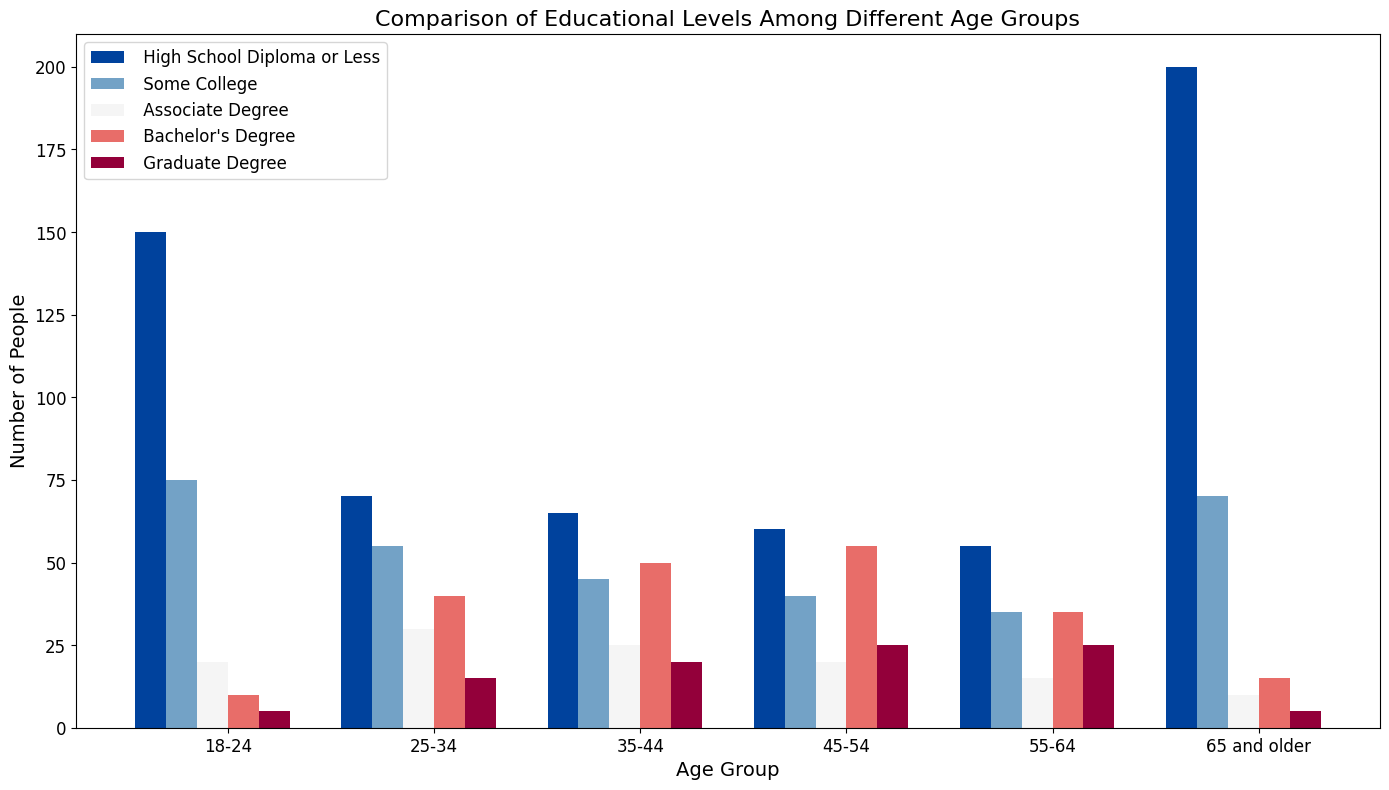What age group has the highest number of people with a High School Diploma or Less? Observe the heights of the bars for "High School Diploma or Less" in each age group. The tallest bar is for the "65 and older" group.
Answer: 65 and older Which age group has more people with a Bachelor's Degree, 35-44 or 45-54? Compare the heights of the bars for "Bachelor's Degree" in the 35-44 and 45-54 age groups. The 45-54 age group has a taller bar.
Answer: 45-54 What is the total number of people with Graduate Degrees in the 25-34 and 55-64 age groups? Find the numbers for "Graduate Degree" in the 25-34 and 55-64 age groups and add them together: 15 + 25.
Answer: 40 Which age group has the smallest number of people with an Associate Degree? Compare the heights of the bars for "Associate Degree" in each age group. The shortest bar is for the "65 and older" group.
Answer: 65 and older How does the number of people with Some College in the 18-24 age group compare to the 65 and older age group? Observe the heights of the bars for "Some College" in the 18-24 and 65 and older age groups. Both bars are about the same height.
Answer: Equal Which educational level has the most people in the 45-54 age group? Look at the heights of all bars in the 45-54 age group. The tallest bar is for "Bachelor's Degree".
Answer: Bachelor's Degree How many more people have a High School Diploma or Less in the 18-24 age group compared to the 25-34 age group? Subtract the number for "High School Diploma or Less" in the 25-34 age group from the 18-24 age group: 150 - 70.
Answer: 80 Which age group has the greatest variation in educational levels? Look at the differences in bar heights within each age group. The 18-24 and 65 and older groups show significant variation. The 65 and older group has the largest variation.
Answer: 65 and older Is there any age group where more people have Graduate Degrees than Bachelor's Degrees? Compare the "Graduate Degree" and "Bachelor's Degree" bar heights within each age group. No age group has more "Graduate Degree" holders than "Bachelor's Degree" holders.
Answer: No 